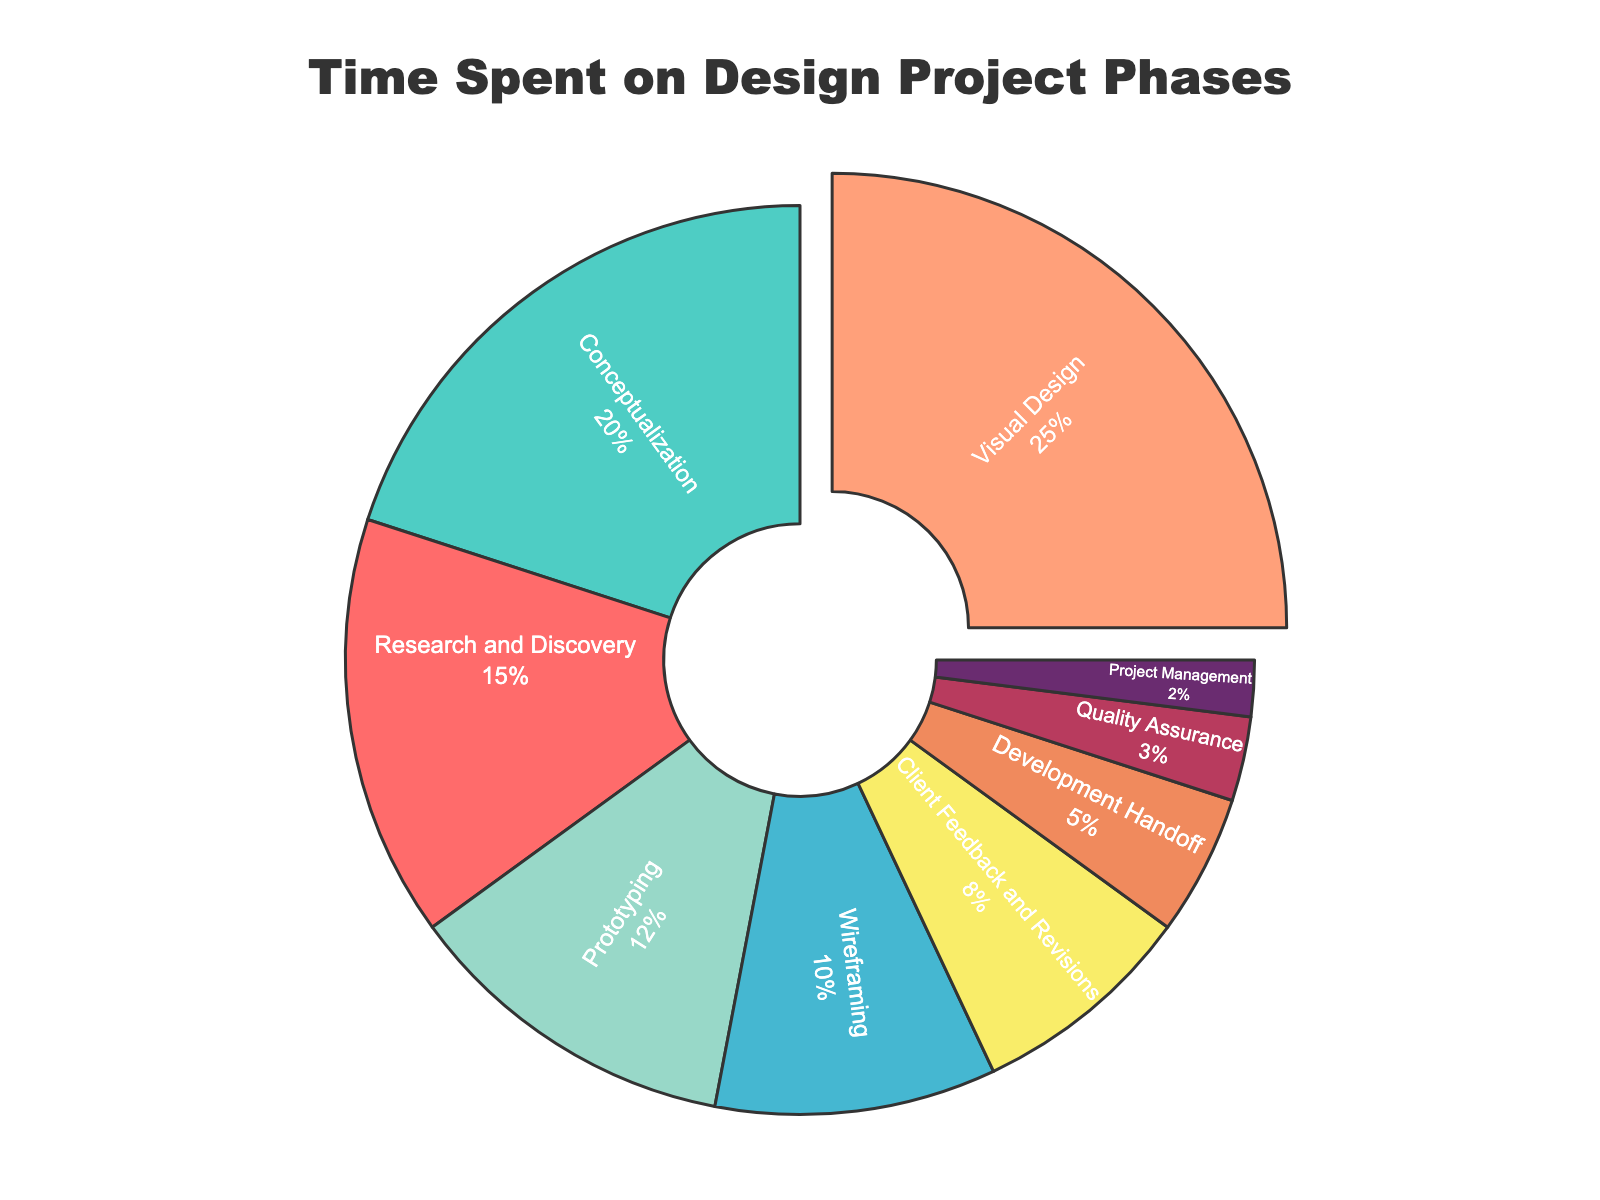what is the phase with the highest percentage? The phase with the highest percentage is visually identified by its larger segment size in the chart, and it’s specifically pulled out from the pie chart. According to the chart, it is Visual Design.
Answer: Visual Design what is the total percentage spent on Client Feedback and Revisions and Development Handoff? Add the percentages of Client Feedback and Revisions (8%) and Development Handoff (5%). 8 + 5 = 13%
Answer: 13% which phase spends exactly 10 percent? Identify the phase whose segment is labeled with 10% inside the pie chart. According to the figure, it is Wireframing.
Answer: Wireframing which phase uses the green color in the chart? Examine the pie chart to identify the segment colored green. The label inside this green segment is Client Feedback and Revisions.
Answer: Client Feedback and Revisions how many phases have a percentage less than 10? Identify all phases with percentages less than 10%. These are Client Feedback and Revisions (8%), Development Handoff (5%), Quality Assurance (3%), and Project Management (2%). There are four such phases.
Answer: 4 how much more percentage is spent on Visual Design compared to Wireframing? Find the difference between the percentage for Visual Design (25%) and Wireframing (10%). 25 - 10 = 15%
Answer: 15% is the percentage spent on Prototyping greater than that spent on Wireframing? Compare the percentage of Prototyping (12%) with Wireframing (10%). Since 12 > 10, Prototyping has a greater percentage.
Answer: Yes what is the second largest segment on the pie chart? The segment sizes indicate the amount of time spent, so the second largest segment corresponds to the second highest percentage. According to the chart, Conceptualization is the second largest with 20%.
Answer: Conceptualization which color represents the Research and Discovery phase? Identify the color of the segment labeled Research and Discovery in the pie chart. The segment is colored red.
Answer: Red what is the combined percentage of phases that include feedback or revisions? Sum the percentages of all phases that include feedback or revisions. Only Client Feedback and Revisions (8%) fits this criterion. The combined percentage is 8%.
Answer: 8% 